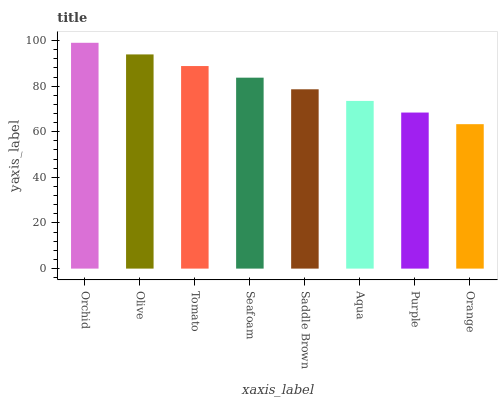Is Orange the minimum?
Answer yes or no. Yes. Is Orchid the maximum?
Answer yes or no. Yes. Is Olive the minimum?
Answer yes or no. No. Is Olive the maximum?
Answer yes or no. No. Is Orchid greater than Olive?
Answer yes or no. Yes. Is Olive less than Orchid?
Answer yes or no. Yes. Is Olive greater than Orchid?
Answer yes or no. No. Is Orchid less than Olive?
Answer yes or no. No. Is Seafoam the high median?
Answer yes or no. Yes. Is Saddle Brown the low median?
Answer yes or no. Yes. Is Orange the high median?
Answer yes or no. No. Is Orange the low median?
Answer yes or no. No. 